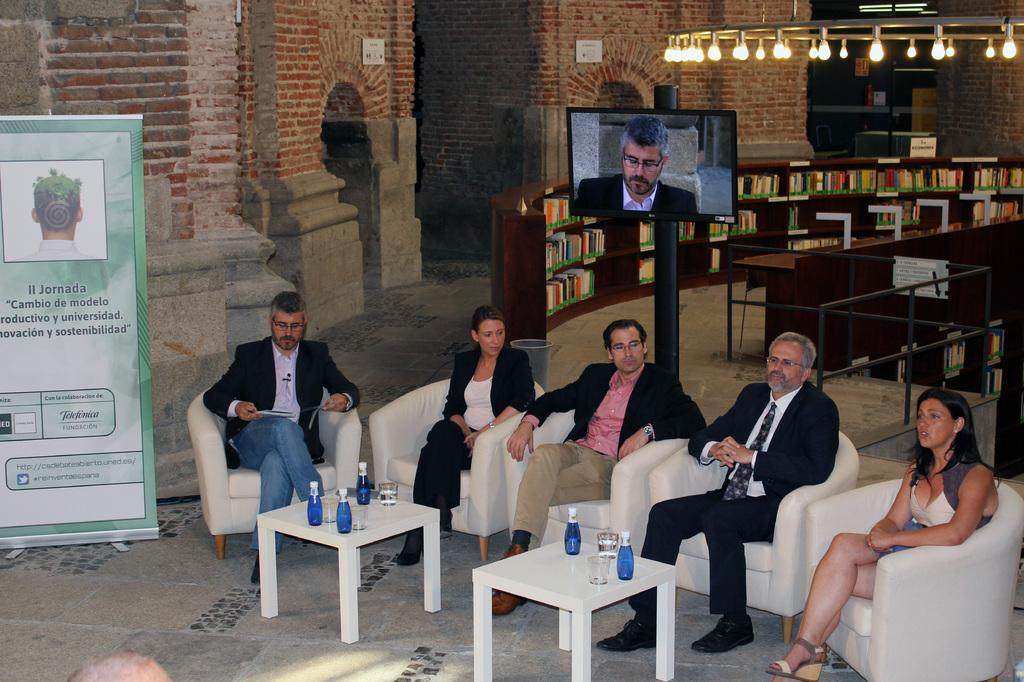What are the people in the image doing? The people in the image are sitting on chairs. What is in front of the chairs? There is a table in front of the chairs. What can be seen on the table? There are bottles on the table. What is in the background of the image? There is a pole with a TV on it and a bookshelf with books in the background of the image. What type of cable is being used to connect the cap to the vessel in the image? There is no cable, cap, or vessel present in the image. 